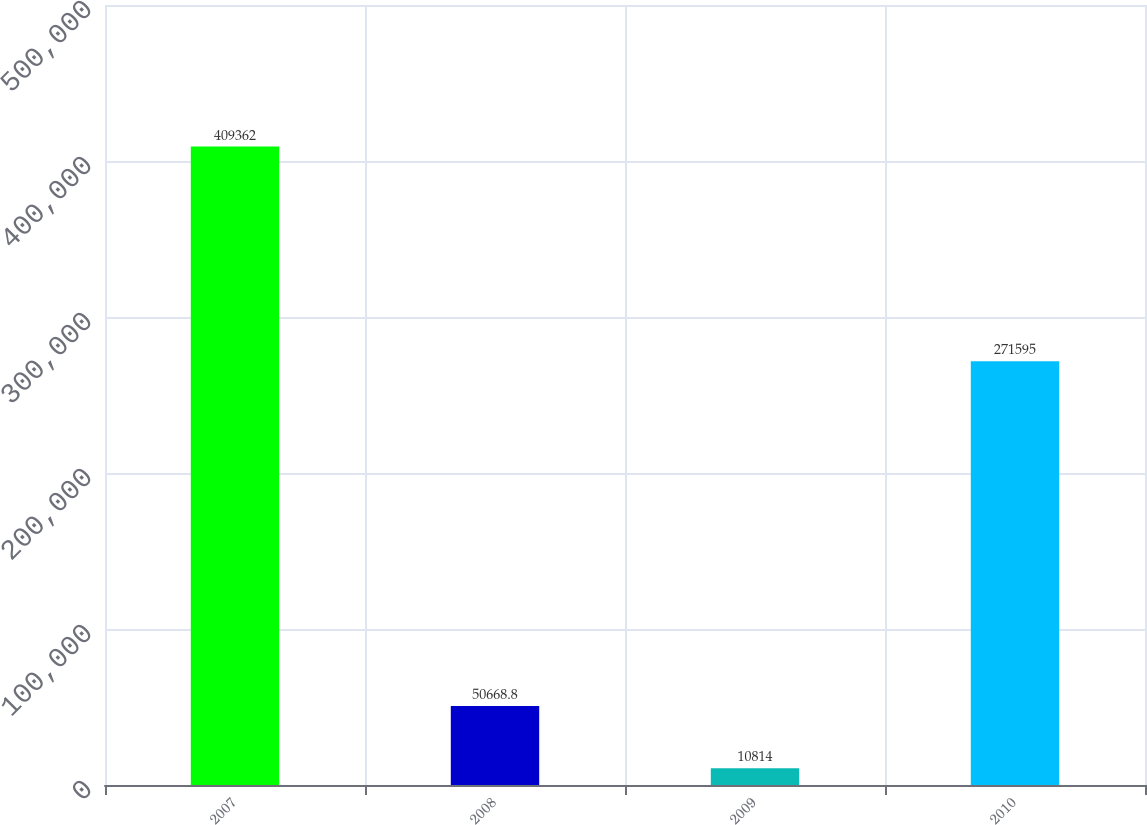Convert chart to OTSL. <chart><loc_0><loc_0><loc_500><loc_500><bar_chart><fcel>2007<fcel>2008<fcel>2009<fcel>2010<nl><fcel>409362<fcel>50668.8<fcel>10814<fcel>271595<nl></chart> 